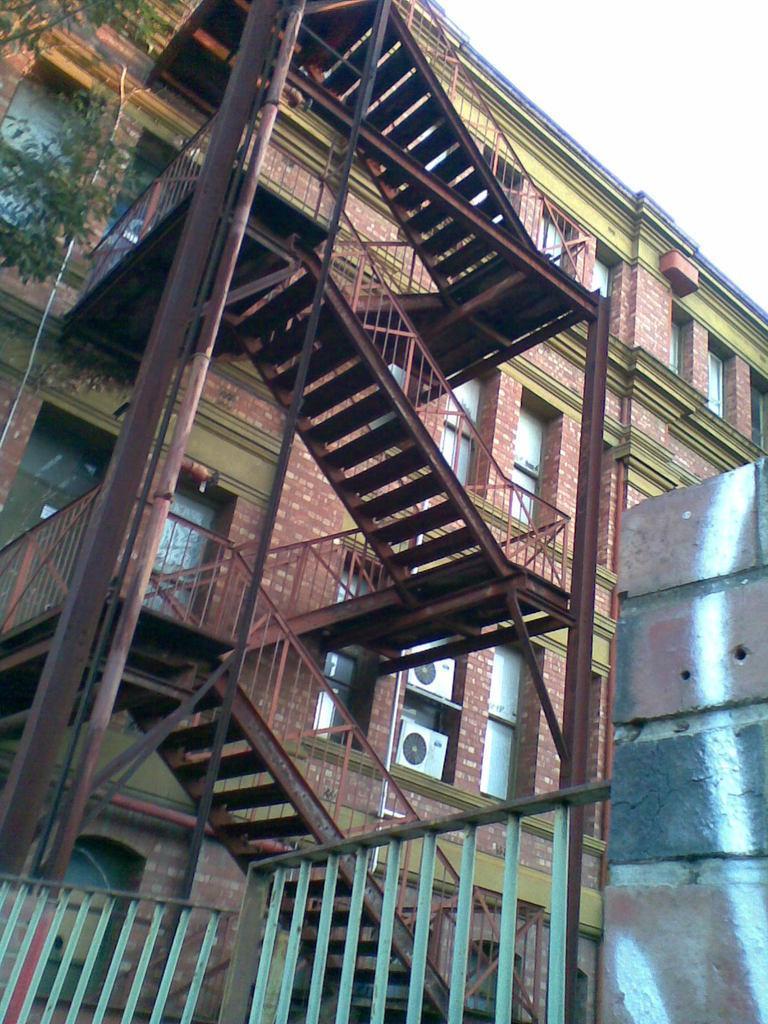In one or two sentences, can you explain what this image depicts? In this picture there is a brown color brick building with many windows. In the front there is a iron staircase with railing pipes. In front bottom side we can see a green color iron gate. 